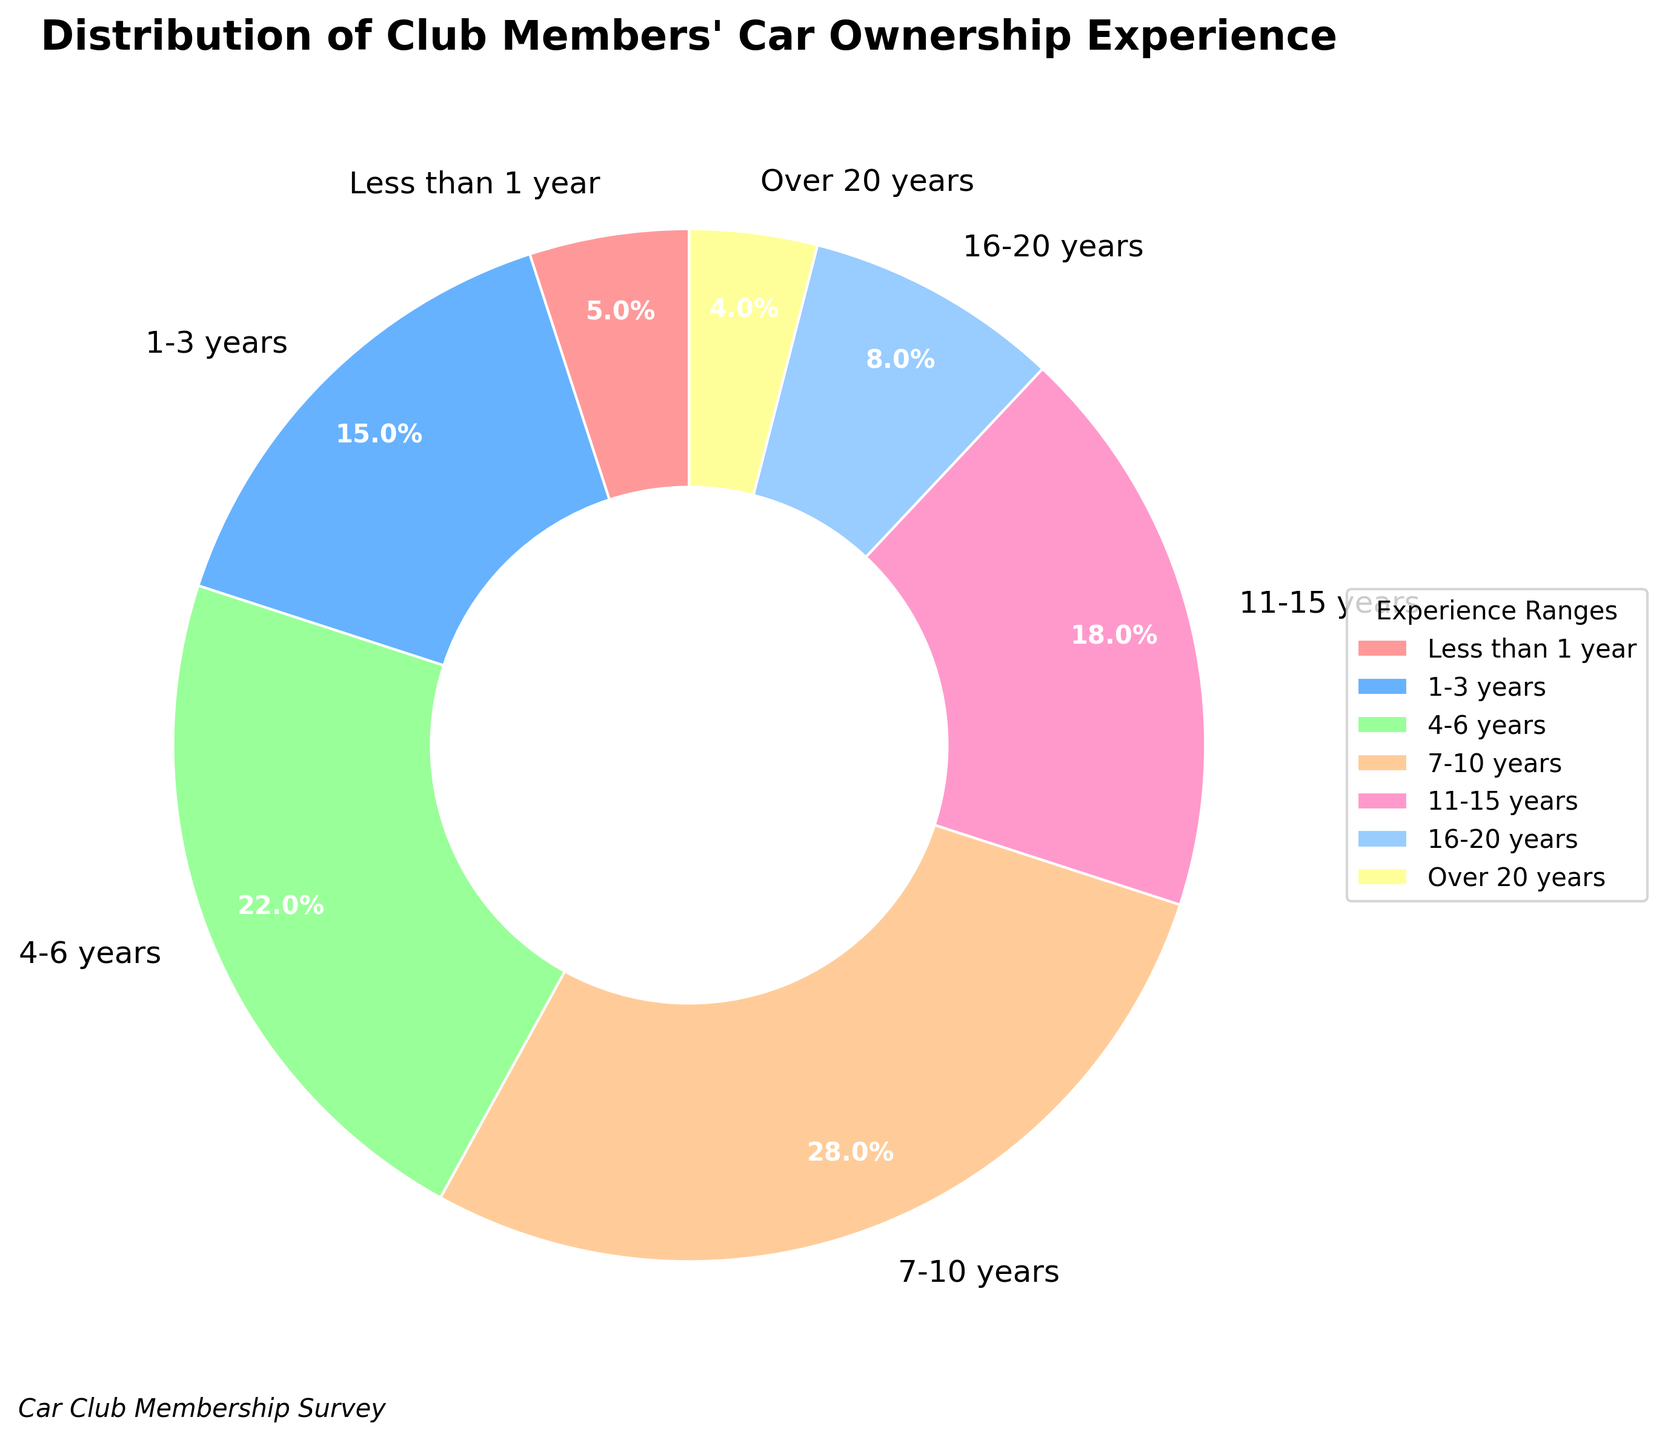What percentage of club members have more than 15 years of experience in car ownership? By referring to the segments in the pie chart, we identify the sections labeled "16-20 years" and "Over 20 years". These sections are 8% and 4% respectively. Their sum gives the total percentage of members with more than 15 years of experience, which is 8 + 4 = 12%.
Answer: 12% Which experience range contains the highest percentage of club members? The largest slice of the pie chart corresponds to the "7-10 years" experience range, which is clearly marked as 28%.
Answer: 7-10 years How much larger is the percentage of members with 7-10 years of experience compared to those with less than 1 year? The "7-10 years" segment is 28%, and the "Less than 1 year" segment is 5%. The difference between them is calculated as 28 - 5 = 23%.
Answer: 23% How does the percentage of members with 4-6 years of experience compare to the percentage of those with 11-15 years of experience? By looking at the pie chart, we see that the "4-6 years" segment is 22% and the "11-15 years" segment is 18%. Therefore, it is clear that members with 4-6 years of experience are more by a difference of 22 - 18 = 4%.
Answer: 4% more Is the percentage of members with 7-10 years of experience alone greater than the combined percentage of members with less than 1 year and 1-3 years? The "7-10 years" segment is 28%. Summarizing the "less than 1 year" (5%) and "1-3 years" (15%) segments gives 5 + 15 = 20%. Since 28% is greater than 20%, the statement is true.
Answer: Yes What is the total percentage of members with up to 3 years of experience? Adding the percentages of "Less than 1 year" (5%) and "1-3 years" (15%), we have 5 + 15 = 20%.
Answer: 20% Among the listed experience ranges, which one occupies the smallest slice of the pie chart? From the visual observation of the sizes of the pie segments, the smallest slice is labeled "Over 20 years" and is marked as 4%.
Answer: Over 20 years How much more percentage of members have 7-10 years of experience compared to those with 16-20 years of experience? The percentage of members with "7-10 years" experience is 28%, while the percentage for "16-20 years" is 8%. Calculating the difference, 28 - 8 = 20%.
Answer: 20% more How could you describe the distribution of experience in the club? The pie chart shows that a significant portion of the members have 7-10 years of experience (28%), followed by those with 4-6 years (22%) and 11-15 years (18%). Smaller percentages are seen in the ranges "less than 1 year" (5%), "1-3 years" (15%), "16-20 years" (8%), and "over 20 years" (4%), indicating a balanced mix but with a concentration in mid-range experience.
Answer: Balanced with mid-range concentration How does the combined percentage of members with 4-10 years of experience compare with those from other experience ranges? Combining "4-6 years" (22%) and "7-10 years" (28%) results in 22 + 28 = 50%. Observation shows that this combined percentage (50%) is higher than the sum of the other ranges. The remaining percentages are "less than 1 year" (5%), "1-3 years" (15%), "11-15 years" (18%), "16-20 years" (8%), and "over 20 years" (4%). These total to 5 + 15 + 18 + 8 + 4 = 50%, which is equal but spread over more categories.
Answer: Equal 